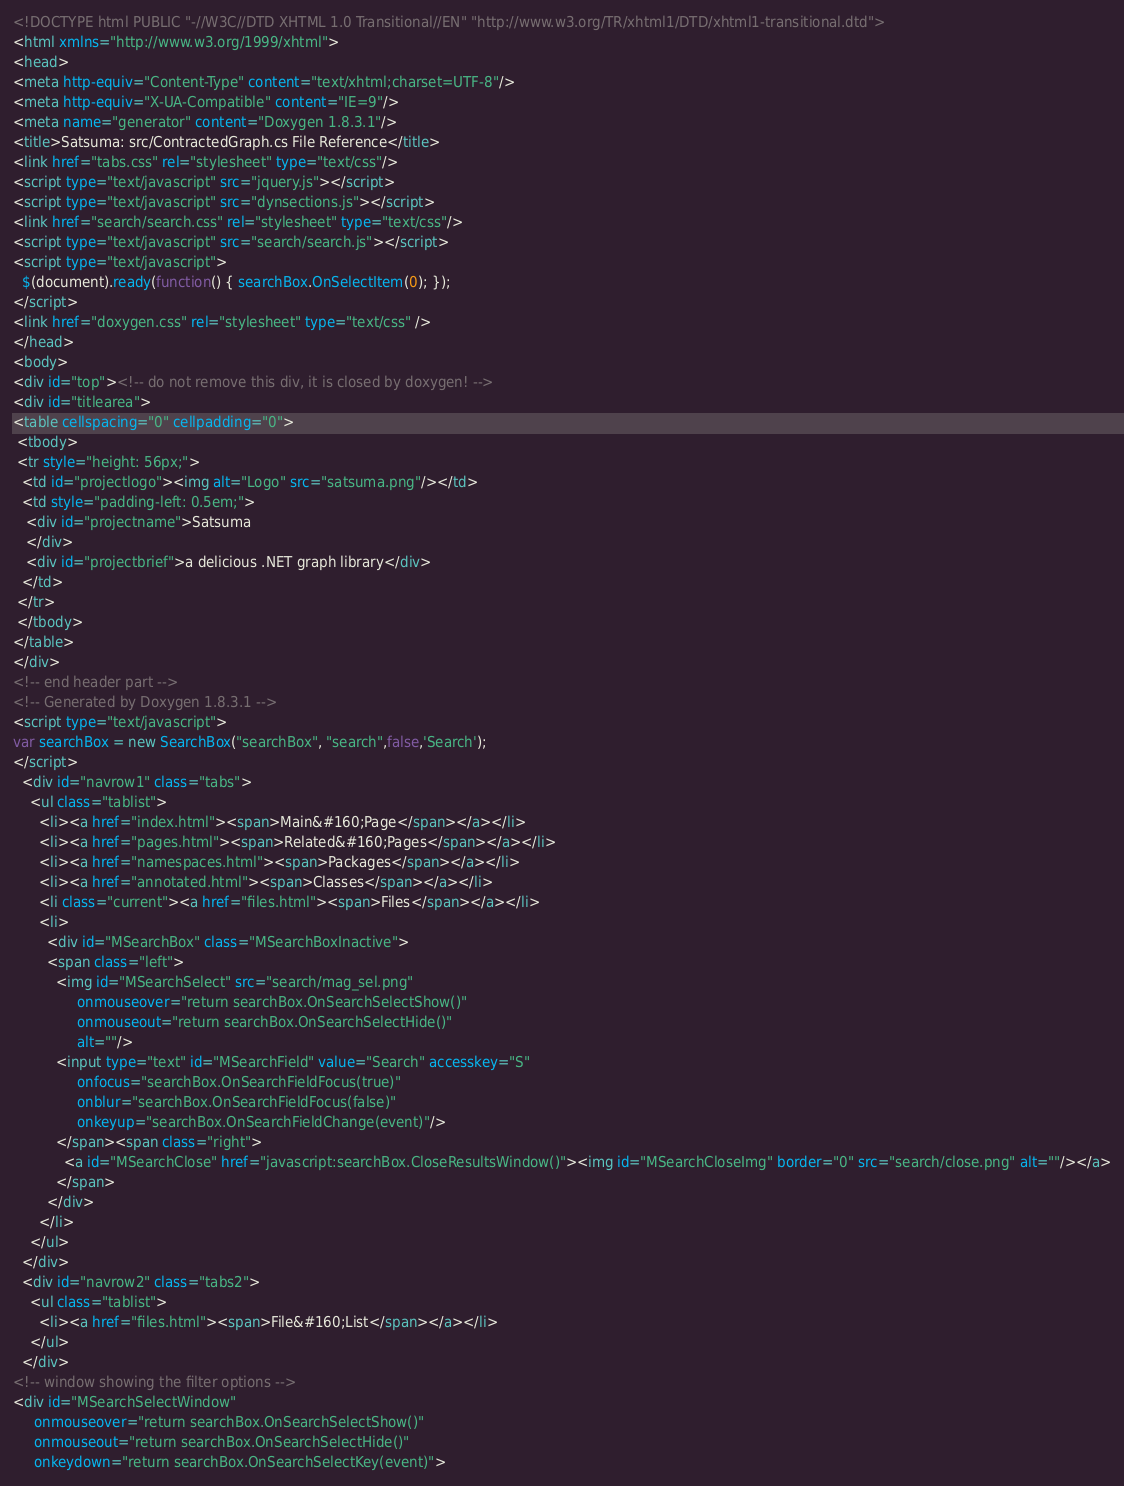Convert code to text. <code><loc_0><loc_0><loc_500><loc_500><_HTML_><!DOCTYPE html PUBLIC "-//W3C//DTD XHTML 1.0 Transitional//EN" "http://www.w3.org/TR/xhtml1/DTD/xhtml1-transitional.dtd">
<html xmlns="http://www.w3.org/1999/xhtml">
<head>
<meta http-equiv="Content-Type" content="text/xhtml;charset=UTF-8"/>
<meta http-equiv="X-UA-Compatible" content="IE=9"/>
<meta name="generator" content="Doxygen 1.8.3.1"/>
<title>Satsuma: src/ContractedGraph.cs File Reference</title>
<link href="tabs.css" rel="stylesheet" type="text/css"/>
<script type="text/javascript" src="jquery.js"></script>
<script type="text/javascript" src="dynsections.js"></script>
<link href="search/search.css" rel="stylesheet" type="text/css"/>
<script type="text/javascript" src="search/search.js"></script>
<script type="text/javascript">
  $(document).ready(function() { searchBox.OnSelectItem(0); });
</script>
<link href="doxygen.css" rel="stylesheet" type="text/css" />
</head>
<body>
<div id="top"><!-- do not remove this div, it is closed by doxygen! -->
<div id="titlearea">
<table cellspacing="0" cellpadding="0">
 <tbody>
 <tr style="height: 56px;">
  <td id="projectlogo"><img alt="Logo" src="satsuma.png"/></td>
  <td style="padding-left: 0.5em;">
   <div id="projectname">Satsuma
   </div>
   <div id="projectbrief">a delicious .NET graph library</div>
  </td>
 </tr>
 </tbody>
</table>
</div>
<!-- end header part -->
<!-- Generated by Doxygen 1.8.3.1 -->
<script type="text/javascript">
var searchBox = new SearchBox("searchBox", "search",false,'Search');
</script>
  <div id="navrow1" class="tabs">
    <ul class="tablist">
      <li><a href="index.html"><span>Main&#160;Page</span></a></li>
      <li><a href="pages.html"><span>Related&#160;Pages</span></a></li>
      <li><a href="namespaces.html"><span>Packages</span></a></li>
      <li><a href="annotated.html"><span>Classes</span></a></li>
      <li class="current"><a href="files.html"><span>Files</span></a></li>
      <li>
        <div id="MSearchBox" class="MSearchBoxInactive">
        <span class="left">
          <img id="MSearchSelect" src="search/mag_sel.png"
               onmouseover="return searchBox.OnSearchSelectShow()"
               onmouseout="return searchBox.OnSearchSelectHide()"
               alt=""/>
          <input type="text" id="MSearchField" value="Search" accesskey="S"
               onfocus="searchBox.OnSearchFieldFocus(true)" 
               onblur="searchBox.OnSearchFieldFocus(false)" 
               onkeyup="searchBox.OnSearchFieldChange(event)"/>
          </span><span class="right">
            <a id="MSearchClose" href="javascript:searchBox.CloseResultsWindow()"><img id="MSearchCloseImg" border="0" src="search/close.png" alt=""/></a>
          </span>
        </div>
      </li>
    </ul>
  </div>
  <div id="navrow2" class="tabs2">
    <ul class="tablist">
      <li><a href="files.html"><span>File&#160;List</span></a></li>
    </ul>
  </div>
<!-- window showing the filter options -->
<div id="MSearchSelectWindow"
     onmouseover="return searchBox.OnSearchSelectShow()"
     onmouseout="return searchBox.OnSearchSelectHide()"
     onkeydown="return searchBox.OnSearchSelectKey(event)"></code> 